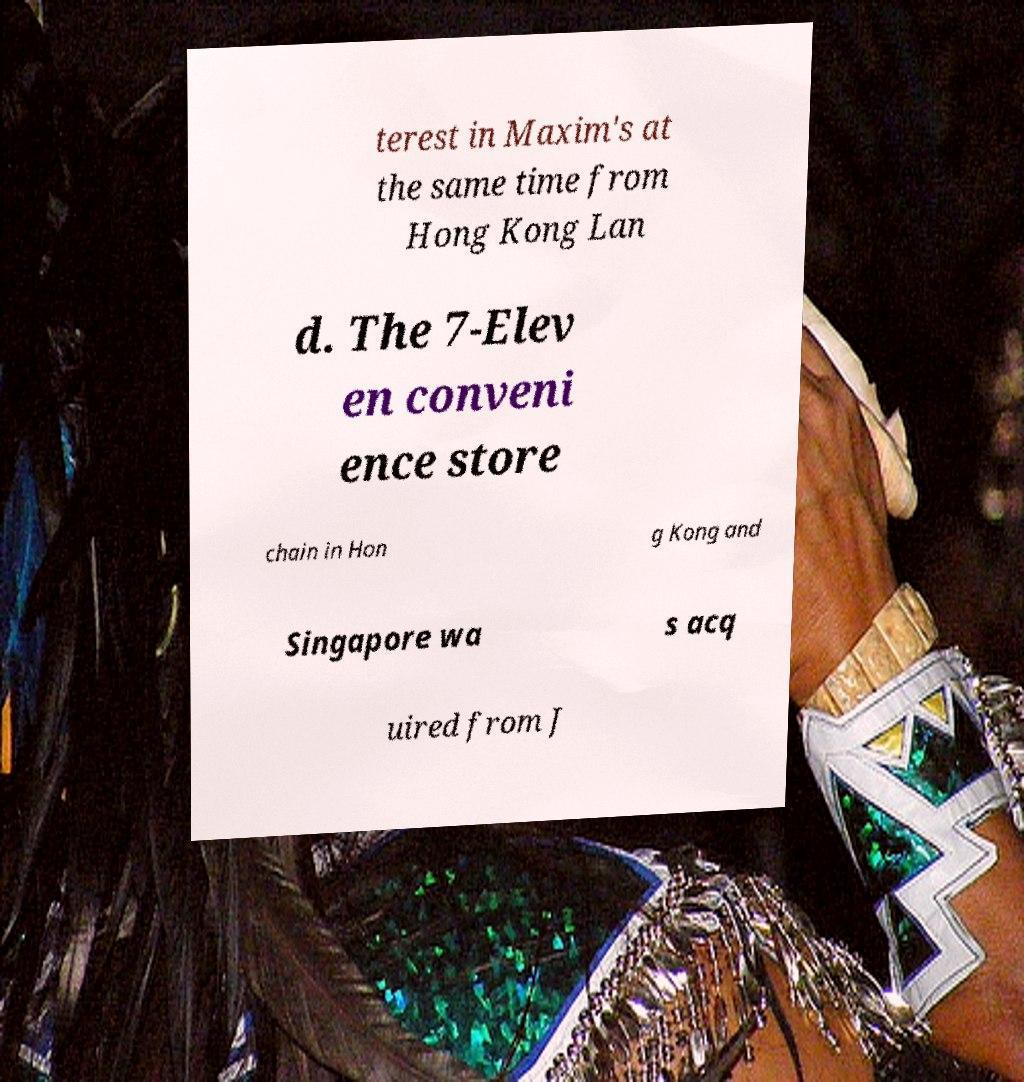Could you assist in decoding the text presented in this image and type it out clearly? terest in Maxim's at the same time from Hong Kong Lan d. The 7-Elev en conveni ence store chain in Hon g Kong and Singapore wa s acq uired from J 